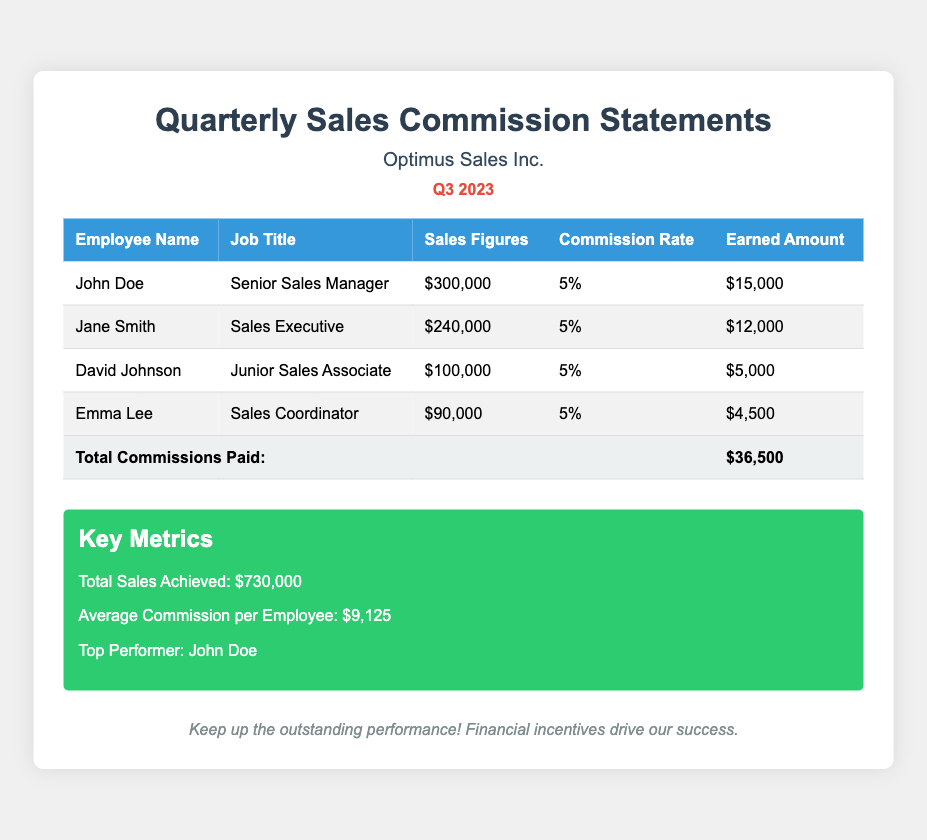What is the total sales achieved? The total sales achieved is clearly stated in the document as the sum of all sales figures from employees, which is $730,000.
Answer: $730,000 Who is the top performer? The document identifies the top performer based on earned amounts, which is John Doe.
Answer: John Doe What is the commission rate for all employees? All employees are listed with the same commission rate of 5%, as shown in their respective columns.
Answer: 5% How much did Jane Smith earn? The earned amount for Jane Smith is specified directly in the document as $12,000.
Answer: $12,000 What is the average commission per employee? The average commission is calculated based on total commissions divided by the number of employees, stated as $9,125.
Answer: $9,125 Which job title does Emma Lee hold? Emma Lee's job title is mentioned in the document, listed as Sales Coordinator.
Answer: Sales Coordinator What is the total commission paid? The total commissions paid is displayed at the end of the table as $36,500.
Answer: $36,500 How many employees are listed in this document? The document includes a count of all employees mentioned in the table, which totals to 4.
Answer: 4 What is the size of John Doe's sales figures? John Doe's sales figures are explicitly stated as $300,000 in the document.
Answer: $300,000 